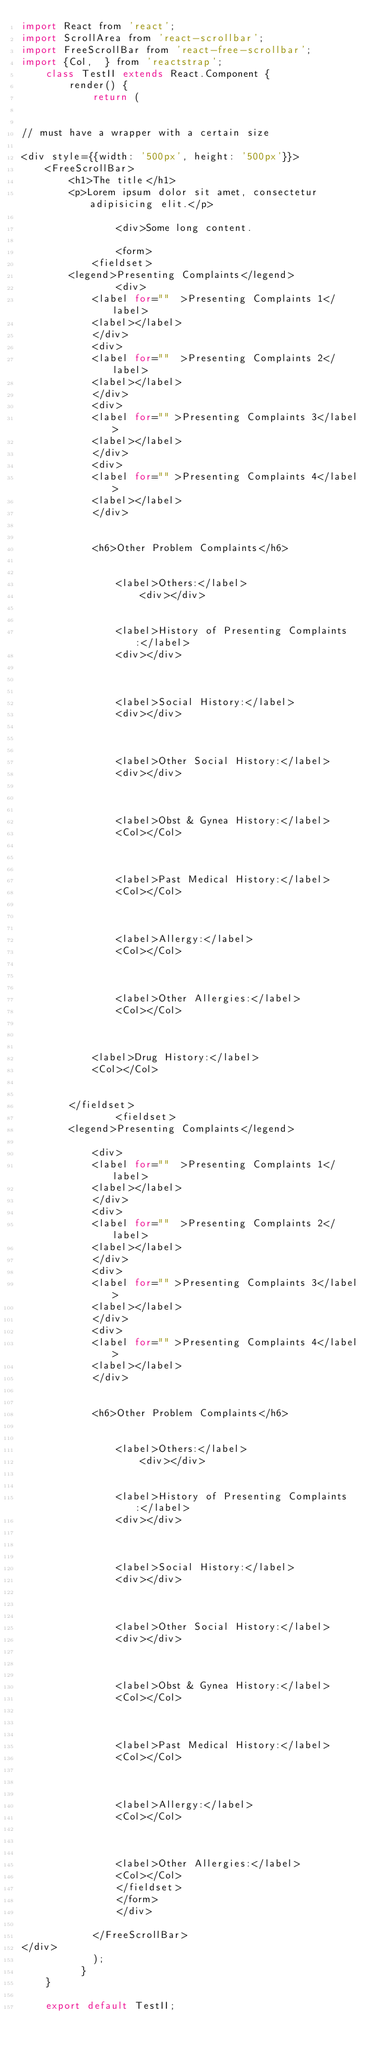<code> <loc_0><loc_0><loc_500><loc_500><_JavaScript_>import React from 'react';
import ScrollArea from 'react-scrollbar';
import FreeScrollBar from 'react-free-scrollbar';
import {Col,  } from 'reactstrap';
    class TestII extends React.Component {
        render() {
            return (
                

// must have a wrapper with a certain size

<div style={{width: '500px', height: '500px'}}>
    <FreeScrollBar>
        <h1>The title</h1>
        <p>Lorem ipsum dolor sit amet, consectetur adipisicing elit.</p>

                <div>Some long content.
                    
                <form>
            <fieldset>    	
				<legend>Presenting Complaints</legend>
                <div>
            <label for=""  >Presenting Complaints 1</label>
            <label></label>
            </div>
            <div>
            <label for=""  >Presenting Complaints 2</label>
            <label></label>
            </div>
            <div>
            <label for="" >Presenting Complaints 3</label>
            <label></label>
            </div>
            <div>
            <label for="" >Presenting Complaints 4</label>
            <label></label>
            </div>
            

            <h6>Other Problem Complaints</h6>
        
            
                <label>Others:</label>
                    <div></div>          
            
        
                <label>History of Presenting Complaints:</label> 
                <div></div>
                
            
        
                <label>Social History:</label>
                <div></div>
                    
            
        
                <label>Other Social History:</label> 
                <div></div>
                
            
        
                <label>Obst & Gynea History:</label> 
                <Col></Col>
                
            
        
                <label>Past Medical History:</label> 
                <Col></Col>
                
            
        
                <label>Allergy:</label> 
                <Col></Col>
                
            
        
                <label>Other Allergies:</label> 
                <Col></Col>
                
            
        
            <label>Drug History:</label> 
            <Col></Col>
            
					
				</fieldset>				
                <fieldset>    	
				<legend>Presenting Complaints</legend>
                
            <div>
            <label for=""  >Presenting Complaints 1</label>
            <label></label>
            </div>
            <div>
            <label for=""  >Presenting Complaints 2</label>
            <label></label>
            </div>
            <div>
            <label for="" >Presenting Complaints 3</label>
            <label></label>
            </div>
            <div>
            <label for="" >Presenting Complaints 4</label>
            <label></label>
            </div>
            

            <h6>Other Problem Complaints</h6>
        
            
                <label>Others:</label>
                    <div></div>          
            
        
                <label>History of Presenting Complaints:</label> 
                <div></div>
                
            
        
                <label>Social History:</label>
                <div></div>
                    
            
        
                <label>Other Social History:</label> 
                <div></div>
                
            
        
                <label>Obst & Gynea History:</label> 
                <Col></Col>
                
            
        
                <label>Past Medical History:</label> 
                <Col></Col>
                
            
        
                <label>Allergy:</label> 
                <Col></Col>
                
            
        
                <label>Other Allergies:</label> 
                <Col></Col>
                </fieldset>
                </form>
                </div>
                
            </FreeScrollBar>
</div>
            );
          }
    }

    export default TestII;</code> 